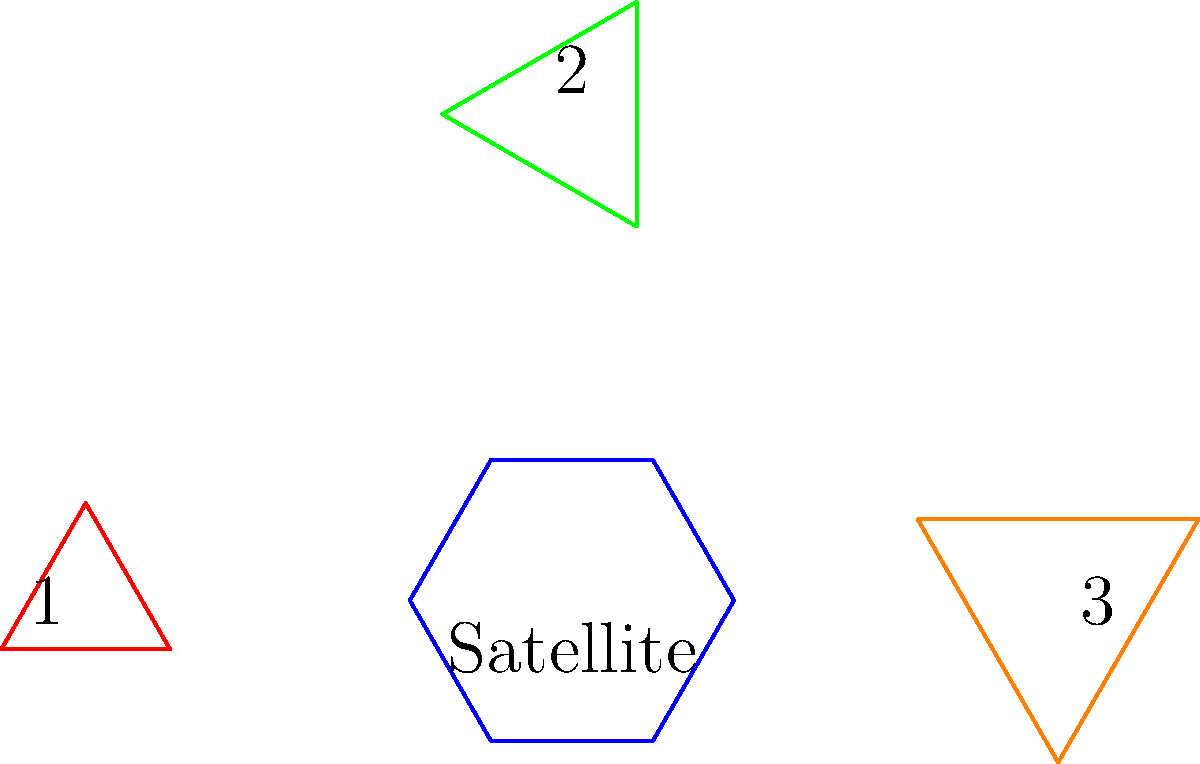Based on the diagram, which is the correct deployment sequence for the multi-stage satellite antenna, assuming the largest antenna deploys last? To determine the correct deployment sequence, we need to analyze the sizes and positions of the antennas:

1. The satellite is represented by the blue hexagon in the center.
2. There are three antennas, represented by triangles:
   - Antenna 1 (red) on the left
   - Antenna 2 (green) on the top
   - Antenna 3 (orange) on the right

3. Comparing the sizes of the antennas:
   - Antenna 1 is the smallest
   - Antenna 2 is medium-sized
   - Antenna 3 is the largest

4. Given that the largest antenna deploys last, we know that Antenna 3 will be the final stage.

5. The logical sequence would be to deploy from smallest to largest:
   - First: Antenna 1 (smallest)
   - Second: Antenna 2 (medium)
   - Third: Antenna 3 (largest)

Therefore, the correct deployment sequence is 1-2-3.
Answer: 1-2-3 